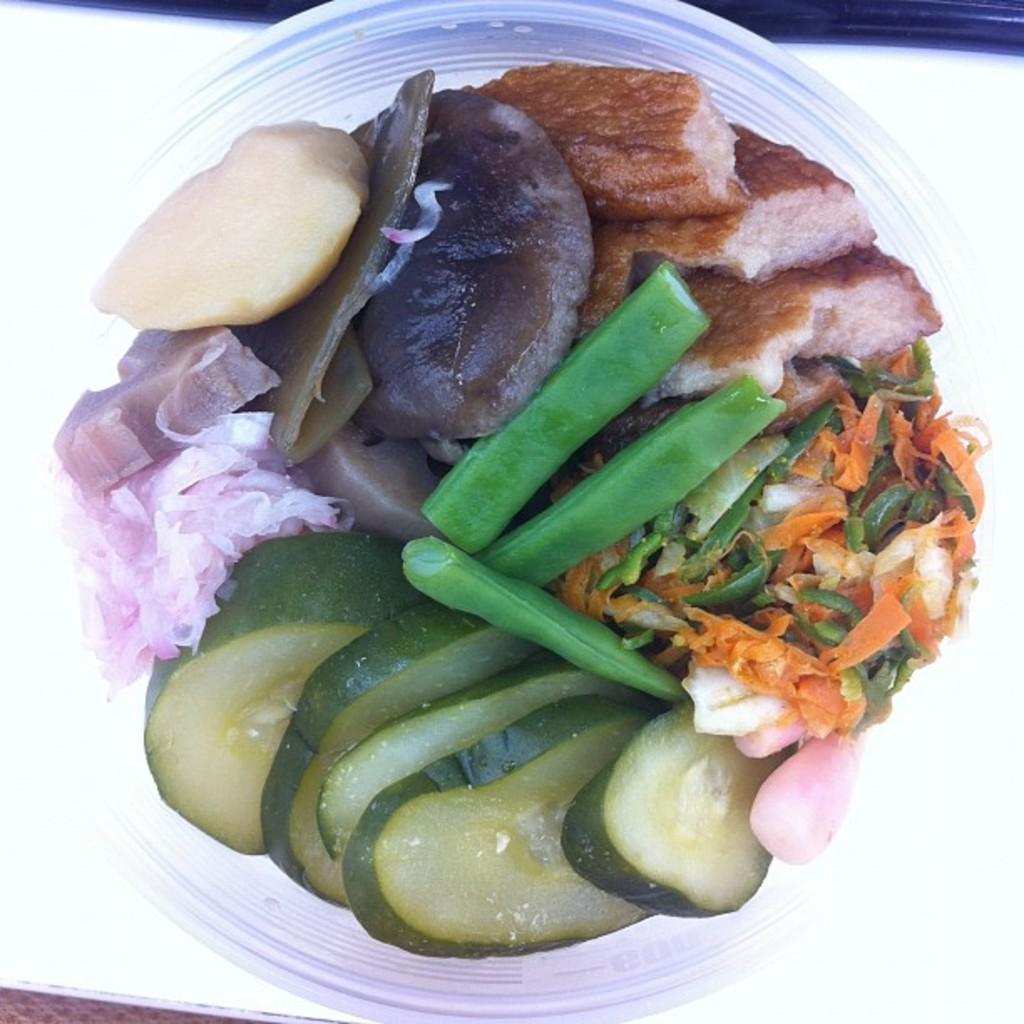In one or two sentences, can you explain what this image depicts? In the image I can see a bowl in which there are some slices of onion, carrot and some other vegetables and food items. 